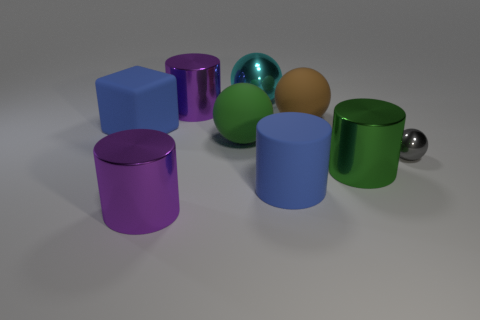What material is the big purple thing behind the big green matte sphere on the left side of the green metallic object made of?
Your response must be concise. Metal. What number of things are blue blocks to the left of the big cyan metal object or big metal objects on the left side of the big rubber cylinder?
Offer a very short reply. 4. What number of other things are there of the same size as the cyan shiny thing?
Provide a short and direct response. 7. Is the color of the big shiny cylinder in front of the green metal thing the same as the cube?
Offer a very short reply. No. There is a cylinder that is both to the left of the cyan sphere and in front of the large green cylinder; what size is it?
Keep it short and to the point. Large. How many big things are red blocks or purple cylinders?
Make the answer very short. 2. There is a large purple thing that is in front of the rubber block; what shape is it?
Give a very brief answer. Cylinder. How many large metal things are there?
Offer a very short reply. 4. Do the block and the brown sphere have the same material?
Give a very brief answer. Yes. Are there more green things behind the big blue rubber cube than large green objects?
Keep it short and to the point. No. 